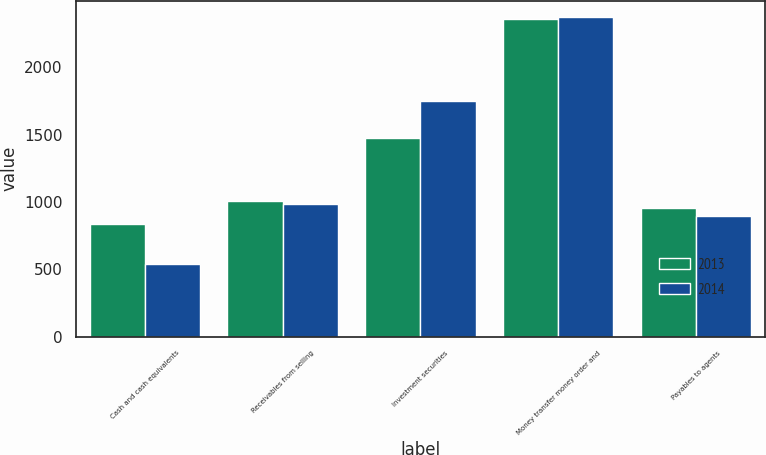Convert chart to OTSL. <chart><loc_0><loc_0><loc_500><loc_500><stacked_bar_chart><ecel><fcel>Cash and cash equivalents<fcel>Receivables from selling<fcel>Investment securities<fcel>Money transfer money order and<fcel>Payables to agents<nl><fcel>2013<fcel>834.3<fcel>1006.9<fcel>1472.5<fcel>2356.7<fcel>957<nl><fcel>2014<fcel>538.6<fcel>981.3<fcel>1750.5<fcel>2376.6<fcel>893.8<nl></chart> 